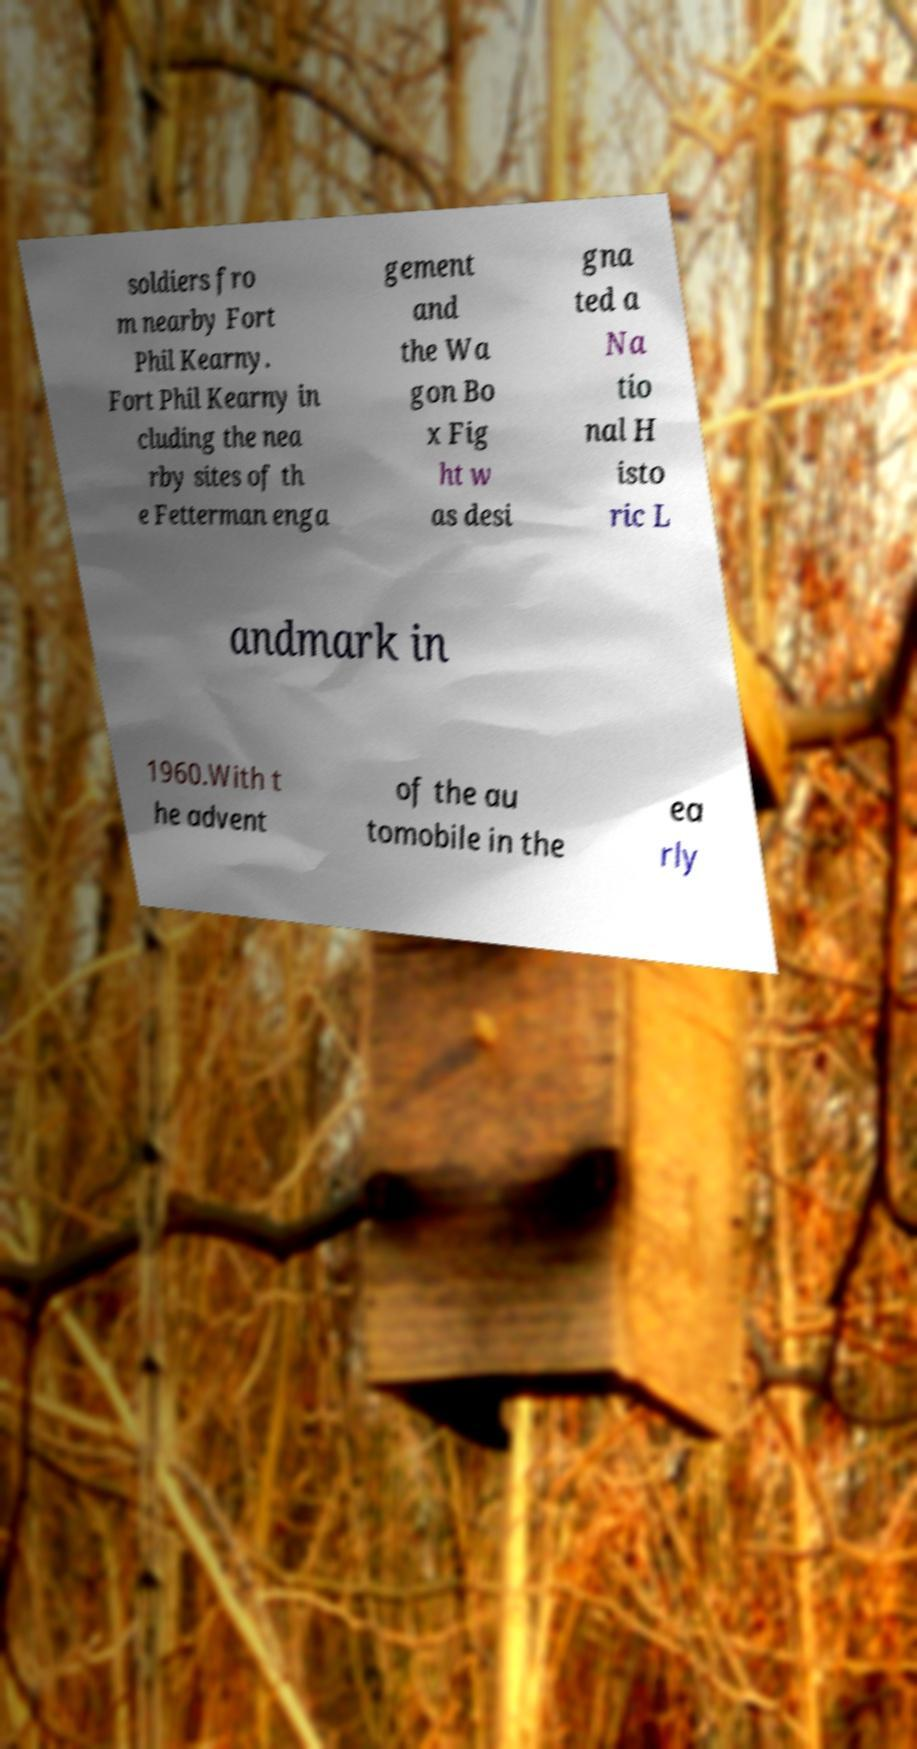Please read and relay the text visible in this image. What does it say? soldiers fro m nearby Fort Phil Kearny. Fort Phil Kearny in cluding the nea rby sites of th e Fetterman enga gement and the Wa gon Bo x Fig ht w as desi gna ted a Na tio nal H isto ric L andmark in 1960.With t he advent of the au tomobile in the ea rly 